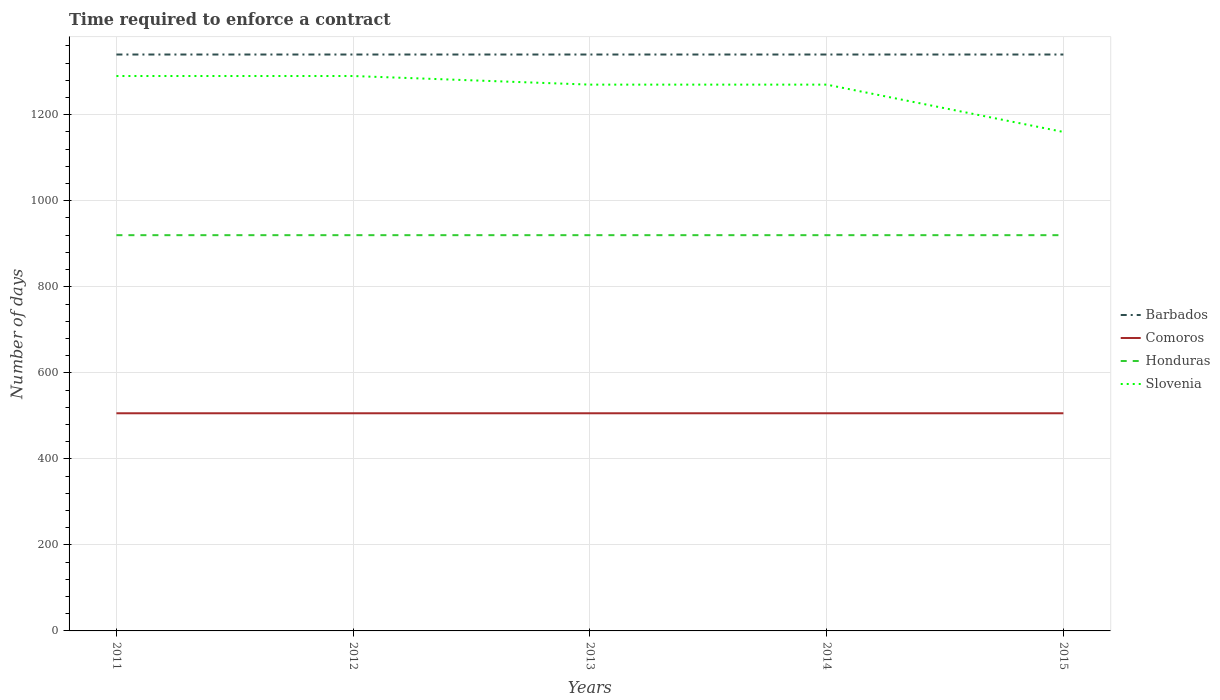Is the number of lines equal to the number of legend labels?
Offer a terse response. Yes. Across all years, what is the maximum number of days required to enforce a contract in Barbados?
Keep it short and to the point. 1340. In which year was the number of days required to enforce a contract in Comoros maximum?
Your response must be concise. 2011. What is the total number of days required to enforce a contract in Honduras in the graph?
Offer a very short reply. 0. What is the difference between the highest and the second highest number of days required to enforce a contract in Comoros?
Your response must be concise. 0. What is the difference between the highest and the lowest number of days required to enforce a contract in Slovenia?
Give a very brief answer. 4. Is the number of days required to enforce a contract in Slovenia strictly greater than the number of days required to enforce a contract in Honduras over the years?
Your answer should be compact. No. How many years are there in the graph?
Make the answer very short. 5. What is the difference between two consecutive major ticks on the Y-axis?
Provide a short and direct response. 200. Does the graph contain any zero values?
Your answer should be very brief. No. Does the graph contain grids?
Offer a terse response. Yes. How many legend labels are there?
Provide a succinct answer. 4. What is the title of the graph?
Keep it short and to the point. Time required to enforce a contract. Does "East Asia (all income levels)" appear as one of the legend labels in the graph?
Provide a short and direct response. No. What is the label or title of the Y-axis?
Keep it short and to the point. Number of days. What is the Number of days in Barbados in 2011?
Offer a terse response. 1340. What is the Number of days of Comoros in 2011?
Offer a terse response. 506. What is the Number of days of Honduras in 2011?
Your answer should be very brief. 920. What is the Number of days of Slovenia in 2011?
Offer a very short reply. 1290. What is the Number of days of Barbados in 2012?
Offer a very short reply. 1340. What is the Number of days of Comoros in 2012?
Make the answer very short. 506. What is the Number of days of Honduras in 2012?
Make the answer very short. 920. What is the Number of days of Slovenia in 2012?
Your answer should be very brief. 1290. What is the Number of days of Barbados in 2013?
Keep it short and to the point. 1340. What is the Number of days of Comoros in 2013?
Give a very brief answer. 506. What is the Number of days in Honduras in 2013?
Your answer should be compact. 920. What is the Number of days in Slovenia in 2013?
Provide a short and direct response. 1270. What is the Number of days of Barbados in 2014?
Ensure brevity in your answer.  1340. What is the Number of days of Comoros in 2014?
Offer a terse response. 506. What is the Number of days of Honduras in 2014?
Your answer should be compact. 920. What is the Number of days in Slovenia in 2014?
Provide a succinct answer. 1270. What is the Number of days in Barbados in 2015?
Give a very brief answer. 1340. What is the Number of days in Comoros in 2015?
Offer a terse response. 506. What is the Number of days of Honduras in 2015?
Your answer should be compact. 920. What is the Number of days in Slovenia in 2015?
Make the answer very short. 1160. Across all years, what is the maximum Number of days of Barbados?
Your answer should be compact. 1340. Across all years, what is the maximum Number of days in Comoros?
Make the answer very short. 506. Across all years, what is the maximum Number of days in Honduras?
Your response must be concise. 920. Across all years, what is the maximum Number of days in Slovenia?
Provide a short and direct response. 1290. Across all years, what is the minimum Number of days in Barbados?
Your answer should be very brief. 1340. Across all years, what is the minimum Number of days of Comoros?
Provide a succinct answer. 506. Across all years, what is the minimum Number of days of Honduras?
Offer a terse response. 920. Across all years, what is the minimum Number of days in Slovenia?
Provide a short and direct response. 1160. What is the total Number of days of Barbados in the graph?
Provide a short and direct response. 6700. What is the total Number of days in Comoros in the graph?
Provide a succinct answer. 2530. What is the total Number of days of Honduras in the graph?
Make the answer very short. 4600. What is the total Number of days in Slovenia in the graph?
Provide a short and direct response. 6280. What is the difference between the Number of days in Comoros in 2011 and that in 2012?
Offer a very short reply. 0. What is the difference between the Number of days in Honduras in 2011 and that in 2012?
Keep it short and to the point. 0. What is the difference between the Number of days in Barbados in 2011 and that in 2013?
Offer a terse response. 0. What is the difference between the Number of days in Comoros in 2011 and that in 2013?
Ensure brevity in your answer.  0. What is the difference between the Number of days of Barbados in 2011 and that in 2014?
Provide a succinct answer. 0. What is the difference between the Number of days in Honduras in 2011 and that in 2014?
Provide a short and direct response. 0. What is the difference between the Number of days in Slovenia in 2011 and that in 2014?
Provide a succinct answer. 20. What is the difference between the Number of days in Barbados in 2011 and that in 2015?
Your answer should be very brief. 0. What is the difference between the Number of days in Comoros in 2011 and that in 2015?
Give a very brief answer. 0. What is the difference between the Number of days of Honduras in 2011 and that in 2015?
Offer a very short reply. 0. What is the difference between the Number of days of Slovenia in 2011 and that in 2015?
Your answer should be very brief. 130. What is the difference between the Number of days of Barbados in 2012 and that in 2013?
Your answer should be very brief. 0. What is the difference between the Number of days in Comoros in 2012 and that in 2013?
Offer a very short reply. 0. What is the difference between the Number of days of Slovenia in 2012 and that in 2013?
Your response must be concise. 20. What is the difference between the Number of days in Comoros in 2012 and that in 2014?
Ensure brevity in your answer.  0. What is the difference between the Number of days of Honduras in 2012 and that in 2014?
Offer a terse response. 0. What is the difference between the Number of days of Slovenia in 2012 and that in 2014?
Your response must be concise. 20. What is the difference between the Number of days in Barbados in 2012 and that in 2015?
Your answer should be compact. 0. What is the difference between the Number of days of Honduras in 2012 and that in 2015?
Give a very brief answer. 0. What is the difference between the Number of days in Slovenia in 2012 and that in 2015?
Provide a succinct answer. 130. What is the difference between the Number of days in Barbados in 2013 and that in 2014?
Keep it short and to the point. 0. What is the difference between the Number of days in Slovenia in 2013 and that in 2014?
Provide a short and direct response. 0. What is the difference between the Number of days in Barbados in 2013 and that in 2015?
Give a very brief answer. 0. What is the difference between the Number of days of Honduras in 2013 and that in 2015?
Make the answer very short. 0. What is the difference between the Number of days of Slovenia in 2013 and that in 2015?
Offer a very short reply. 110. What is the difference between the Number of days in Slovenia in 2014 and that in 2015?
Your response must be concise. 110. What is the difference between the Number of days in Barbados in 2011 and the Number of days in Comoros in 2012?
Give a very brief answer. 834. What is the difference between the Number of days in Barbados in 2011 and the Number of days in Honduras in 2012?
Offer a very short reply. 420. What is the difference between the Number of days of Comoros in 2011 and the Number of days of Honduras in 2012?
Your answer should be very brief. -414. What is the difference between the Number of days of Comoros in 2011 and the Number of days of Slovenia in 2012?
Offer a very short reply. -784. What is the difference between the Number of days in Honduras in 2011 and the Number of days in Slovenia in 2012?
Keep it short and to the point. -370. What is the difference between the Number of days in Barbados in 2011 and the Number of days in Comoros in 2013?
Offer a terse response. 834. What is the difference between the Number of days of Barbados in 2011 and the Number of days of Honduras in 2013?
Your answer should be very brief. 420. What is the difference between the Number of days of Barbados in 2011 and the Number of days of Slovenia in 2013?
Give a very brief answer. 70. What is the difference between the Number of days of Comoros in 2011 and the Number of days of Honduras in 2013?
Your response must be concise. -414. What is the difference between the Number of days of Comoros in 2011 and the Number of days of Slovenia in 2013?
Offer a very short reply. -764. What is the difference between the Number of days in Honduras in 2011 and the Number of days in Slovenia in 2013?
Ensure brevity in your answer.  -350. What is the difference between the Number of days in Barbados in 2011 and the Number of days in Comoros in 2014?
Offer a very short reply. 834. What is the difference between the Number of days of Barbados in 2011 and the Number of days of Honduras in 2014?
Give a very brief answer. 420. What is the difference between the Number of days in Comoros in 2011 and the Number of days in Honduras in 2014?
Provide a short and direct response. -414. What is the difference between the Number of days of Comoros in 2011 and the Number of days of Slovenia in 2014?
Make the answer very short. -764. What is the difference between the Number of days in Honduras in 2011 and the Number of days in Slovenia in 2014?
Provide a succinct answer. -350. What is the difference between the Number of days in Barbados in 2011 and the Number of days in Comoros in 2015?
Provide a short and direct response. 834. What is the difference between the Number of days of Barbados in 2011 and the Number of days of Honduras in 2015?
Make the answer very short. 420. What is the difference between the Number of days in Barbados in 2011 and the Number of days in Slovenia in 2015?
Provide a succinct answer. 180. What is the difference between the Number of days in Comoros in 2011 and the Number of days in Honduras in 2015?
Your answer should be compact. -414. What is the difference between the Number of days of Comoros in 2011 and the Number of days of Slovenia in 2015?
Keep it short and to the point. -654. What is the difference between the Number of days of Honduras in 2011 and the Number of days of Slovenia in 2015?
Your answer should be very brief. -240. What is the difference between the Number of days in Barbados in 2012 and the Number of days in Comoros in 2013?
Make the answer very short. 834. What is the difference between the Number of days of Barbados in 2012 and the Number of days of Honduras in 2013?
Provide a short and direct response. 420. What is the difference between the Number of days in Comoros in 2012 and the Number of days in Honduras in 2013?
Ensure brevity in your answer.  -414. What is the difference between the Number of days of Comoros in 2012 and the Number of days of Slovenia in 2013?
Offer a very short reply. -764. What is the difference between the Number of days in Honduras in 2012 and the Number of days in Slovenia in 2013?
Give a very brief answer. -350. What is the difference between the Number of days of Barbados in 2012 and the Number of days of Comoros in 2014?
Make the answer very short. 834. What is the difference between the Number of days of Barbados in 2012 and the Number of days of Honduras in 2014?
Your response must be concise. 420. What is the difference between the Number of days of Barbados in 2012 and the Number of days of Slovenia in 2014?
Your response must be concise. 70. What is the difference between the Number of days of Comoros in 2012 and the Number of days of Honduras in 2014?
Ensure brevity in your answer.  -414. What is the difference between the Number of days of Comoros in 2012 and the Number of days of Slovenia in 2014?
Provide a succinct answer. -764. What is the difference between the Number of days of Honduras in 2012 and the Number of days of Slovenia in 2014?
Your answer should be very brief. -350. What is the difference between the Number of days in Barbados in 2012 and the Number of days in Comoros in 2015?
Keep it short and to the point. 834. What is the difference between the Number of days in Barbados in 2012 and the Number of days in Honduras in 2015?
Your response must be concise. 420. What is the difference between the Number of days in Barbados in 2012 and the Number of days in Slovenia in 2015?
Keep it short and to the point. 180. What is the difference between the Number of days of Comoros in 2012 and the Number of days of Honduras in 2015?
Provide a succinct answer. -414. What is the difference between the Number of days of Comoros in 2012 and the Number of days of Slovenia in 2015?
Make the answer very short. -654. What is the difference between the Number of days in Honduras in 2012 and the Number of days in Slovenia in 2015?
Offer a very short reply. -240. What is the difference between the Number of days in Barbados in 2013 and the Number of days in Comoros in 2014?
Give a very brief answer. 834. What is the difference between the Number of days in Barbados in 2013 and the Number of days in Honduras in 2014?
Provide a succinct answer. 420. What is the difference between the Number of days in Barbados in 2013 and the Number of days in Slovenia in 2014?
Your answer should be very brief. 70. What is the difference between the Number of days in Comoros in 2013 and the Number of days in Honduras in 2014?
Your answer should be compact. -414. What is the difference between the Number of days of Comoros in 2013 and the Number of days of Slovenia in 2014?
Provide a short and direct response. -764. What is the difference between the Number of days of Honduras in 2013 and the Number of days of Slovenia in 2014?
Make the answer very short. -350. What is the difference between the Number of days of Barbados in 2013 and the Number of days of Comoros in 2015?
Offer a terse response. 834. What is the difference between the Number of days of Barbados in 2013 and the Number of days of Honduras in 2015?
Give a very brief answer. 420. What is the difference between the Number of days in Barbados in 2013 and the Number of days in Slovenia in 2015?
Your answer should be very brief. 180. What is the difference between the Number of days in Comoros in 2013 and the Number of days in Honduras in 2015?
Provide a short and direct response. -414. What is the difference between the Number of days of Comoros in 2013 and the Number of days of Slovenia in 2015?
Keep it short and to the point. -654. What is the difference between the Number of days of Honduras in 2013 and the Number of days of Slovenia in 2015?
Your answer should be compact. -240. What is the difference between the Number of days of Barbados in 2014 and the Number of days of Comoros in 2015?
Your answer should be compact. 834. What is the difference between the Number of days in Barbados in 2014 and the Number of days in Honduras in 2015?
Provide a succinct answer. 420. What is the difference between the Number of days of Barbados in 2014 and the Number of days of Slovenia in 2015?
Ensure brevity in your answer.  180. What is the difference between the Number of days of Comoros in 2014 and the Number of days of Honduras in 2015?
Your answer should be very brief. -414. What is the difference between the Number of days of Comoros in 2014 and the Number of days of Slovenia in 2015?
Provide a succinct answer. -654. What is the difference between the Number of days in Honduras in 2014 and the Number of days in Slovenia in 2015?
Ensure brevity in your answer.  -240. What is the average Number of days of Barbados per year?
Offer a terse response. 1340. What is the average Number of days of Comoros per year?
Offer a terse response. 506. What is the average Number of days in Honduras per year?
Provide a succinct answer. 920. What is the average Number of days in Slovenia per year?
Provide a short and direct response. 1256. In the year 2011, what is the difference between the Number of days in Barbados and Number of days in Comoros?
Give a very brief answer. 834. In the year 2011, what is the difference between the Number of days in Barbados and Number of days in Honduras?
Keep it short and to the point. 420. In the year 2011, what is the difference between the Number of days of Comoros and Number of days of Honduras?
Provide a succinct answer. -414. In the year 2011, what is the difference between the Number of days of Comoros and Number of days of Slovenia?
Provide a succinct answer. -784. In the year 2011, what is the difference between the Number of days in Honduras and Number of days in Slovenia?
Provide a short and direct response. -370. In the year 2012, what is the difference between the Number of days of Barbados and Number of days of Comoros?
Your response must be concise. 834. In the year 2012, what is the difference between the Number of days in Barbados and Number of days in Honduras?
Your answer should be compact. 420. In the year 2012, what is the difference between the Number of days in Barbados and Number of days in Slovenia?
Offer a terse response. 50. In the year 2012, what is the difference between the Number of days of Comoros and Number of days of Honduras?
Provide a succinct answer. -414. In the year 2012, what is the difference between the Number of days in Comoros and Number of days in Slovenia?
Keep it short and to the point. -784. In the year 2012, what is the difference between the Number of days in Honduras and Number of days in Slovenia?
Provide a succinct answer. -370. In the year 2013, what is the difference between the Number of days of Barbados and Number of days of Comoros?
Your response must be concise. 834. In the year 2013, what is the difference between the Number of days of Barbados and Number of days of Honduras?
Your answer should be very brief. 420. In the year 2013, what is the difference between the Number of days of Comoros and Number of days of Honduras?
Ensure brevity in your answer.  -414. In the year 2013, what is the difference between the Number of days in Comoros and Number of days in Slovenia?
Your answer should be compact. -764. In the year 2013, what is the difference between the Number of days in Honduras and Number of days in Slovenia?
Your answer should be compact. -350. In the year 2014, what is the difference between the Number of days in Barbados and Number of days in Comoros?
Give a very brief answer. 834. In the year 2014, what is the difference between the Number of days in Barbados and Number of days in Honduras?
Offer a terse response. 420. In the year 2014, what is the difference between the Number of days of Barbados and Number of days of Slovenia?
Your response must be concise. 70. In the year 2014, what is the difference between the Number of days in Comoros and Number of days in Honduras?
Give a very brief answer. -414. In the year 2014, what is the difference between the Number of days in Comoros and Number of days in Slovenia?
Provide a succinct answer. -764. In the year 2014, what is the difference between the Number of days of Honduras and Number of days of Slovenia?
Your answer should be very brief. -350. In the year 2015, what is the difference between the Number of days of Barbados and Number of days of Comoros?
Provide a succinct answer. 834. In the year 2015, what is the difference between the Number of days of Barbados and Number of days of Honduras?
Offer a terse response. 420. In the year 2015, what is the difference between the Number of days of Barbados and Number of days of Slovenia?
Your response must be concise. 180. In the year 2015, what is the difference between the Number of days of Comoros and Number of days of Honduras?
Provide a short and direct response. -414. In the year 2015, what is the difference between the Number of days of Comoros and Number of days of Slovenia?
Ensure brevity in your answer.  -654. In the year 2015, what is the difference between the Number of days of Honduras and Number of days of Slovenia?
Offer a very short reply. -240. What is the ratio of the Number of days in Barbados in 2011 to that in 2012?
Your answer should be very brief. 1. What is the ratio of the Number of days in Comoros in 2011 to that in 2012?
Offer a terse response. 1. What is the ratio of the Number of days of Barbados in 2011 to that in 2013?
Offer a terse response. 1. What is the ratio of the Number of days of Comoros in 2011 to that in 2013?
Keep it short and to the point. 1. What is the ratio of the Number of days in Honduras in 2011 to that in 2013?
Give a very brief answer. 1. What is the ratio of the Number of days in Slovenia in 2011 to that in 2013?
Make the answer very short. 1.02. What is the ratio of the Number of days of Comoros in 2011 to that in 2014?
Keep it short and to the point. 1. What is the ratio of the Number of days in Slovenia in 2011 to that in 2014?
Provide a succinct answer. 1.02. What is the ratio of the Number of days of Barbados in 2011 to that in 2015?
Offer a terse response. 1. What is the ratio of the Number of days in Comoros in 2011 to that in 2015?
Your response must be concise. 1. What is the ratio of the Number of days of Honduras in 2011 to that in 2015?
Provide a short and direct response. 1. What is the ratio of the Number of days in Slovenia in 2011 to that in 2015?
Your answer should be very brief. 1.11. What is the ratio of the Number of days in Slovenia in 2012 to that in 2013?
Provide a short and direct response. 1.02. What is the ratio of the Number of days of Slovenia in 2012 to that in 2014?
Your answer should be compact. 1.02. What is the ratio of the Number of days of Barbados in 2012 to that in 2015?
Give a very brief answer. 1. What is the ratio of the Number of days in Comoros in 2012 to that in 2015?
Offer a very short reply. 1. What is the ratio of the Number of days in Slovenia in 2012 to that in 2015?
Your response must be concise. 1.11. What is the ratio of the Number of days of Barbados in 2013 to that in 2014?
Your answer should be compact. 1. What is the ratio of the Number of days of Slovenia in 2013 to that in 2015?
Your answer should be compact. 1.09. What is the ratio of the Number of days of Comoros in 2014 to that in 2015?
Offer a terse response. 1. What is the ratio of the Number of days in Slovenia in 2014 to that in 2015?
Offer a very short reply. 1.09. What is the difference between the highest and the second highest Number of days of Barbados?
Offer a very short reply. 0. What is the difference between the highest and the second highest Number of days in Comoros?
Offer a very short reply. 0. What is the difference between the highest and the second highest Number of days in Honduras?
Your answer should be very brief. 0. What is the difference between the highest and the lowest Number of days of Barbados?
Your answer should be very brief. 0. What is the difference between the highest and the lowest Number of days of Honduras?
Provide a succinct answer. 0. What is the difference between the highest and the lowest Number of days in Slovenia?
Your response must be concise. 130. 